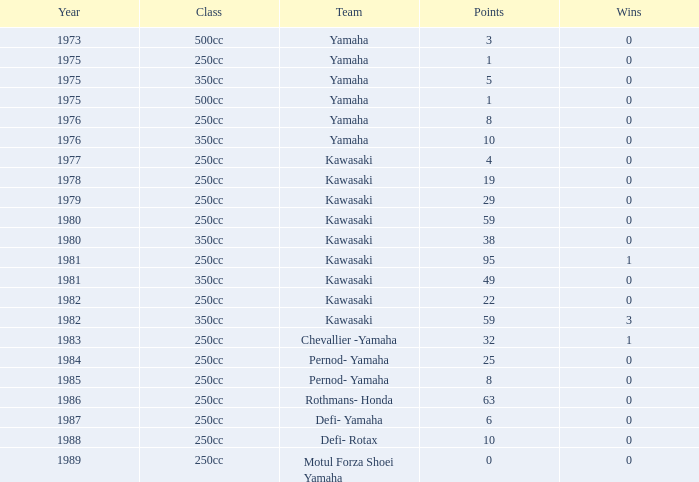In the year immediately before 1981, how many wins did kawasaki's team achieve at their peak with 95 points? None. 